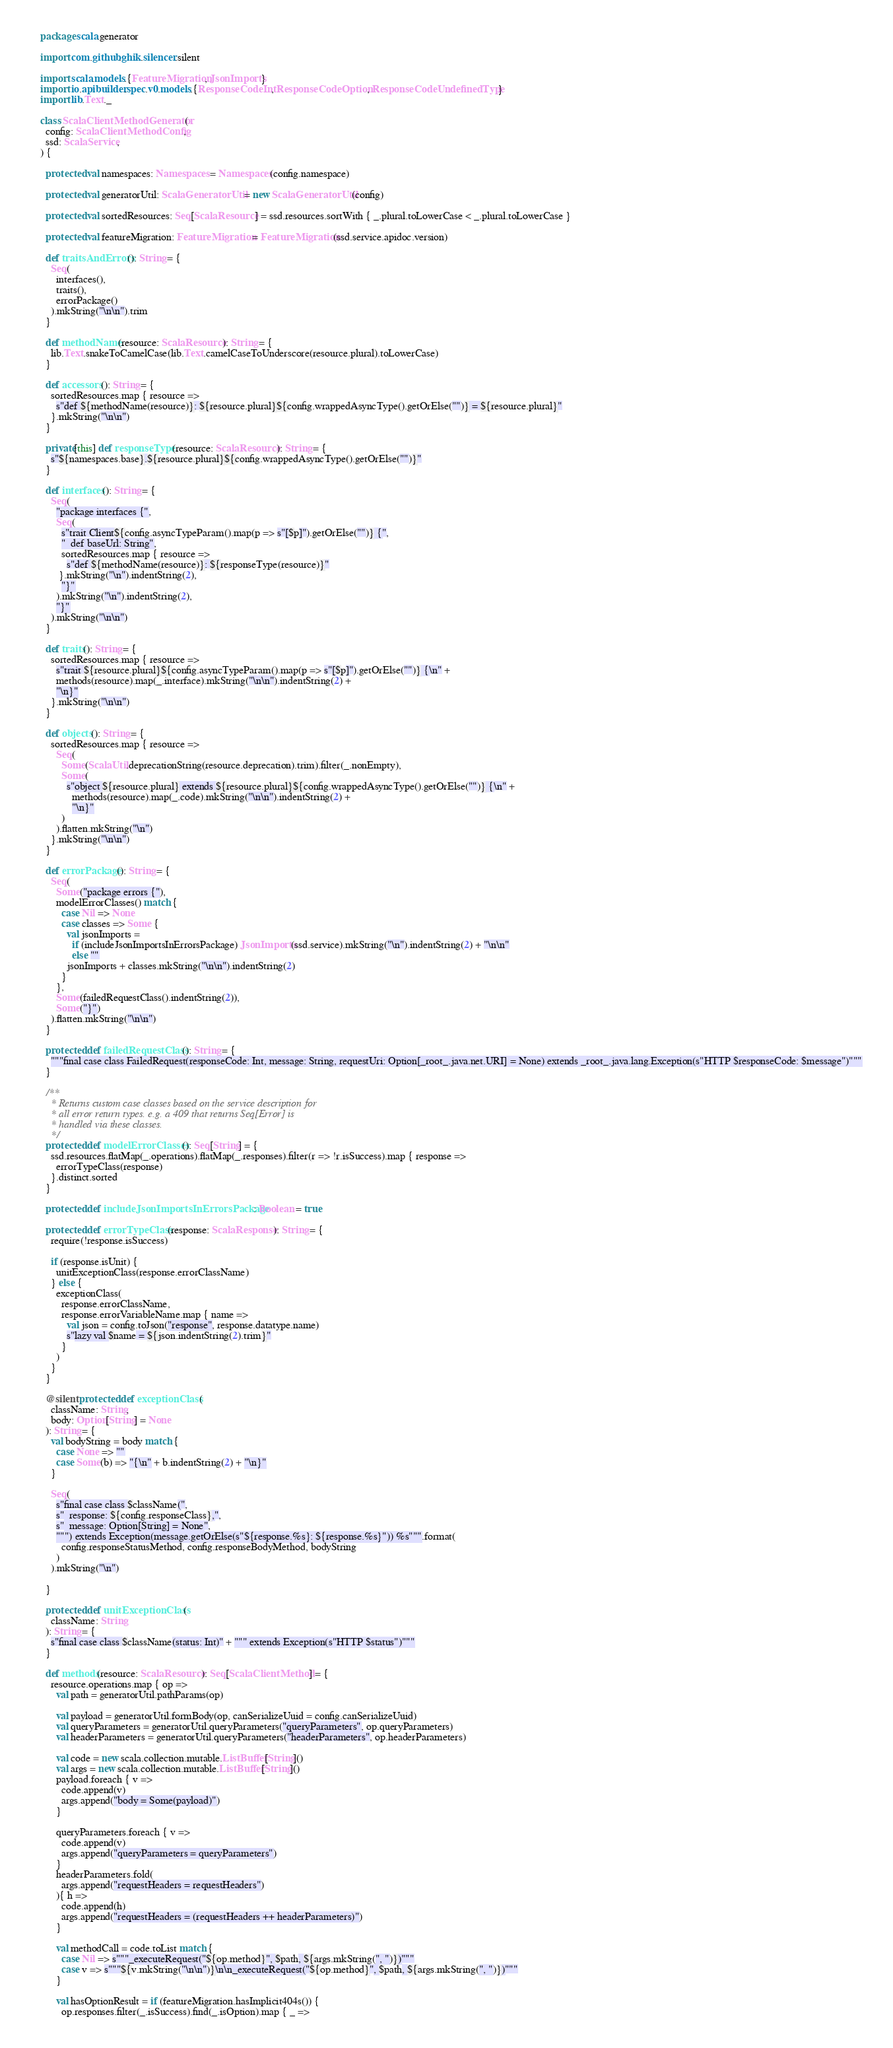Convert code to text. <code><loc_0><loc_0><loc_500><loc_500><_Scala_>package scala.generator

import com.github.ghik.silencer.silent

import scala.models.{FeatureMigration, JsonImports}
import io.apibuilder.spec.v0.models.{ResponseCodeInt, ResponseCodeOption, ResponseCodeUndefinedType}
import lib.Text._

class ScalaClientMethodGenerator(
  config: ScalaClientMethodConfig,
  ssd: ScalaService,
) {

  protected val namespaces: Namespaces = Namespaces(config.namespace)

  protected val generatorUtil: ScalaGeneratorUtil = new ScalaGeneratorUtil(config)

  protected val sortedResources: Seq[ScalaResource] = ssd.resources.sortWith { _.plural.toLowerCase < _.plural.toLowerCase }

  protected val featureMigration: FeatureMigration = FeatureMigration(ssd.service.apidoc.version)

  def traitsAndErrors(): String = {
    Seq(
      interfaces(),
      traits(),
      errorPackage()
    ).mkString("\n\n").trim
  }

  def methodName(resource: ScalaResource): String = {
    lib.Text.snakeToCamelCase(lib.Text.camelCaseToUnderscore(resource.plural).toLowerCase)
  }

  def accessors(): String = {
    sortedResources.map { resource =>
      s"def ${methodName(resource)}: ${resource.plural}${config.wrappedAsyncType().getOrElse("")} = ${resource.plural}"
    }.mkString("\n\n")
  }

  private[this] def responseType(resource: ScalaResource): String = {
    s"${namespaces.base}.${resource.plural}${config.wrappedAsyncType().getOrElse("")}"
  }

  def interfaces(): String = {
    Seq(
      "package interfaces {",
      Seq(
        s"trait Client${config.asyncTypeParam().map(p => s"[$p]").getOrElse("")} {",
        "  def baseUrl: String",
        sortedResources.map { resource =>
          s"def ${methodName(resource)}: ${responseType(resource)}"
       }.mkString("\n").indentString(2),
        "}"
      ).mkString("\n").indentString(2),
      "}"
    ).mkString("\n\n")
  }

  def traits(): String = {
    sortedResources.map { resource =>
      s"trait ${resource.plural}${config.asyncTypeParam().map(p => s"[$p]").getOrElse("")} {\n" +
      methods(resource).map(_.interface).mkString("\n\n").indentString(2) +
      "\n}"
    }.mkString("\n\n")
  }

  def objects(): String = {
    sortedResources.map { resource =>
      Seq(
        Some(ScalaUtil.deprecationString(resource.deprecation).trim).filter(_.nonEmpty),
        Some(
          s"object ${resource.plural} extends ${resource.plural}${config.wrappedAsyncType().getOrElse("")} {\n" +
            methods(resource).map(_.code).mkString("\n\n").indentString(2) +
            "\n}"
        )
      ).flatten.mkString("\n")
    }.mkString("\n\n")
  }

  def errorPackage(): String = {
    Seq(
      Some("package errors {"),
      modelErrorClasses() match {
        case Nil => None
        case classes => Some {
          val jsonImports =
            if (includeJsonImportsInErrorsPackage) JsonImports(ssd.service).mkString("\n").indentString(2) + "\n\n"
            else ""
          jsonImports + classes.mkString("\n\n").indentString(2)
        }
      },
      Some(failedRequestClass().indentString(2)),
      Some("}")
    ).flatten.mkString("\n\n")
  }

  protected def failedRequestClass(): String = {
    """final case class FailedRequest(responseCode: Int, message: String, requestUri: Option[_root_.java.net.URI] = None) extends _root_.java.lang.Exception(s"HTTP $responseCode: $message")"""
  }

  /**
    * Returns custom case classes based on the service description for
    * all error return types. e.g. a 409 that returns Seq[Error] is
    * handled via these classes.
    */
  protected def modelErrorClasses(): Seq[String] = {
    ssd.resources.flatMap(_.operations).flatMap(_.responses).filter(r => !r.isSuccess).map { response =>
      errorTypeClass(response)
    }.distinct.sorted
  }

  protected def includeJsonImportsInErrorsPackage: Boolean = true

  protected def errorTypeClass(response: ScalaResponse): String = {
    require(!response.isSuccess)

    if (response.isUnit) {
      unitExceptionClass(response.errorClassName)
    } else {
      exceptionClass(
        response.errorClassName,
        response.errorVariableName.map { name =>
          val json = config.toJson("response", response.datatype.name)
          s"lazy val $name = ${json.indentString(2).trim}"
        }
      )
    }
  }

  @silent protected def exceptionClass(
    className: String,
    body: Option[String] = None
  ): String = {
    val bodyString = body match {
      case None => ""
      case Some(b) => "{\n" + b.indentString(2) + "\n}"
    }

    Seq(
      s"final case class $className(",
      s"  response: ${config.responseClass},",
      s"  message: Option[String] = None",
      """) extends Exception(message.getOrElse(s"${response.%s}: ${response.%s}")) %s""".format(
        config.responseStatusMethod, config.responseBodyMethod, bodyString
      )
    ).mkString("\n")

  }

  protected def unitExceptionClass(
    className: String
  ): String = {
    s"final case class $className(status: Int)" + """ extends Exception(s"HTTP $status")"""
  }

  def methods(resource: ScalaResource): Seq[ScalaClientMethod] = {
    resource.operations.map { op =>
      val path = generatorUtil.pathParams(op)

      val payload = generatorUtil.formBody(op, canSerializeUuid = config.canSerializeUuid)
      val queryParameters = generatorUtil.queryParameters("queryParameters", op.queryParameters)
      val headerParameters = generatorUtil.queryParameters("headerParameters", op.headerParameters)

      val code = new scala.collection.mutable.ListBuffer[String]()
      val args = new scala.collection.mutable.ListBuffer[String]()
      payload.foreach { v =>
        code.append(v)
        args.append("body = Some(payload)")
      }

      queryParameters.foreach { v =>
        code.append(v)
        args.append("queryParameters = queryParameters")
      }
      headerParameters.fold(
        args.append("requestHeaders = requestHeaders")
      ){ h =>
        code.append(h)
        args.append("requestHeaders = (requestHeaders ++ headerParameters)")
      }

      val methodCall = code.toList match {
        case Nil => s"""_executeRequest("${op.method}", $path, ${args.mkString(", ")})"""
        case v => s"""${v.mkString("\n\n")}\n\n_executeRequest("${op.method}", $path, ${args.mkString(", ")})"""
      }

      val hasOptionResult = if (featureMigration.hasImplicit404s()) {
        op.responses.filter(_.isSuccess).find(_.isOption).map { _ =></code> 